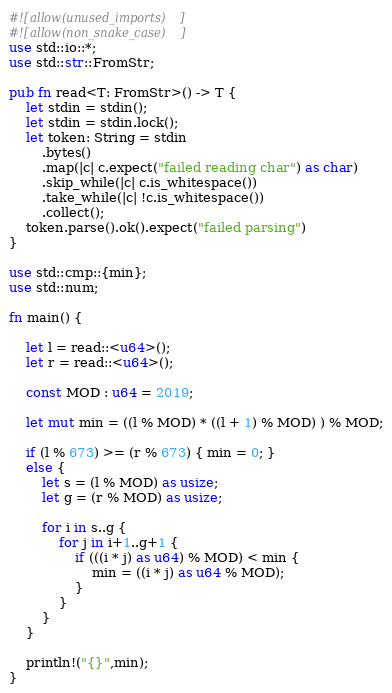<code> <loc_0><loc_0><loc_500><loc_500><_Rust_>#![allow(unused_imports)]
#![allow(non_snake_case)]
use std::io::*;
use std::str::FromStr;

pub fn read<T: FromStr>() -> T {
    let stdin = stdin();
    let stdin = stdin.lock();
    let token: String = stdin
        .bytes()
        .map(|c| c.expect("failed reading char") as char)
        .skip_while(|c| c.is_whitespace())
        .take_while(|c| !c.is_whitespace())
        .collect();
    token.parse().ok().expect("failed parsing")
}

use std::cmp::{min};
use std::num;

fn main() {
    
    let l = read::<u64>();
    let r = read::<u64>();
    
    const MOD : u64 = 2019;
    
    let mut min = ((l % MOD) * ((l + 1) % MOD) ) % MOD;
    
    if (l % 673) >= (r % 673) { min = 0; }
    else {
        let s = (l % MOD) as usize;
        let g = (r % MOD) as usize;
        
        for i in s..g {
            for j in i+1..g+1 {
                if (((i * j) as u64) % MOD) < min {
                    min = ((i * j) as u64 % MOD); 
                }
            }
        }
    }
    
    println!("{}",min);
}</code> 